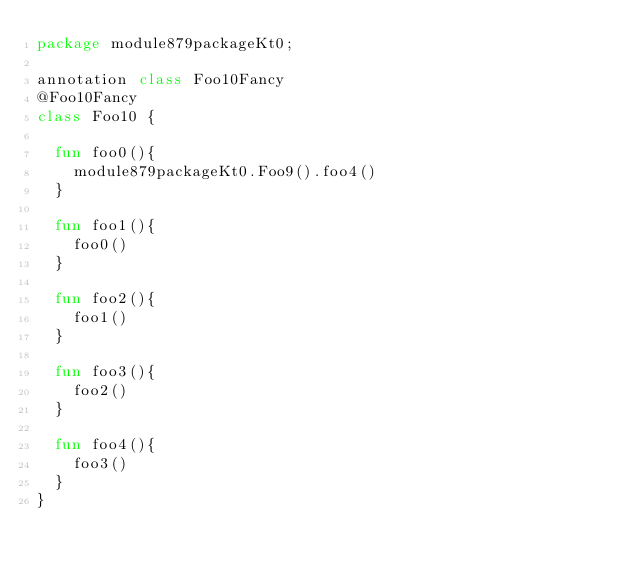<code> <loc_0><loc_0><loc_500><loc_500><_Kotlin_>package module879packageKt0;

annotation class Foo10Fancy
@Foo10Fancy
class Foo10 {

  fun foo0(){
    module879packageKt0.Foo9().foo4()
  }

  fun foo1(){
    foo0()
  }

  fun foo2(){
    foo1()
  }

  fun foo3(){
    foo2()
  }

  fun foo4(){
    foo3()
  }
}</code> 